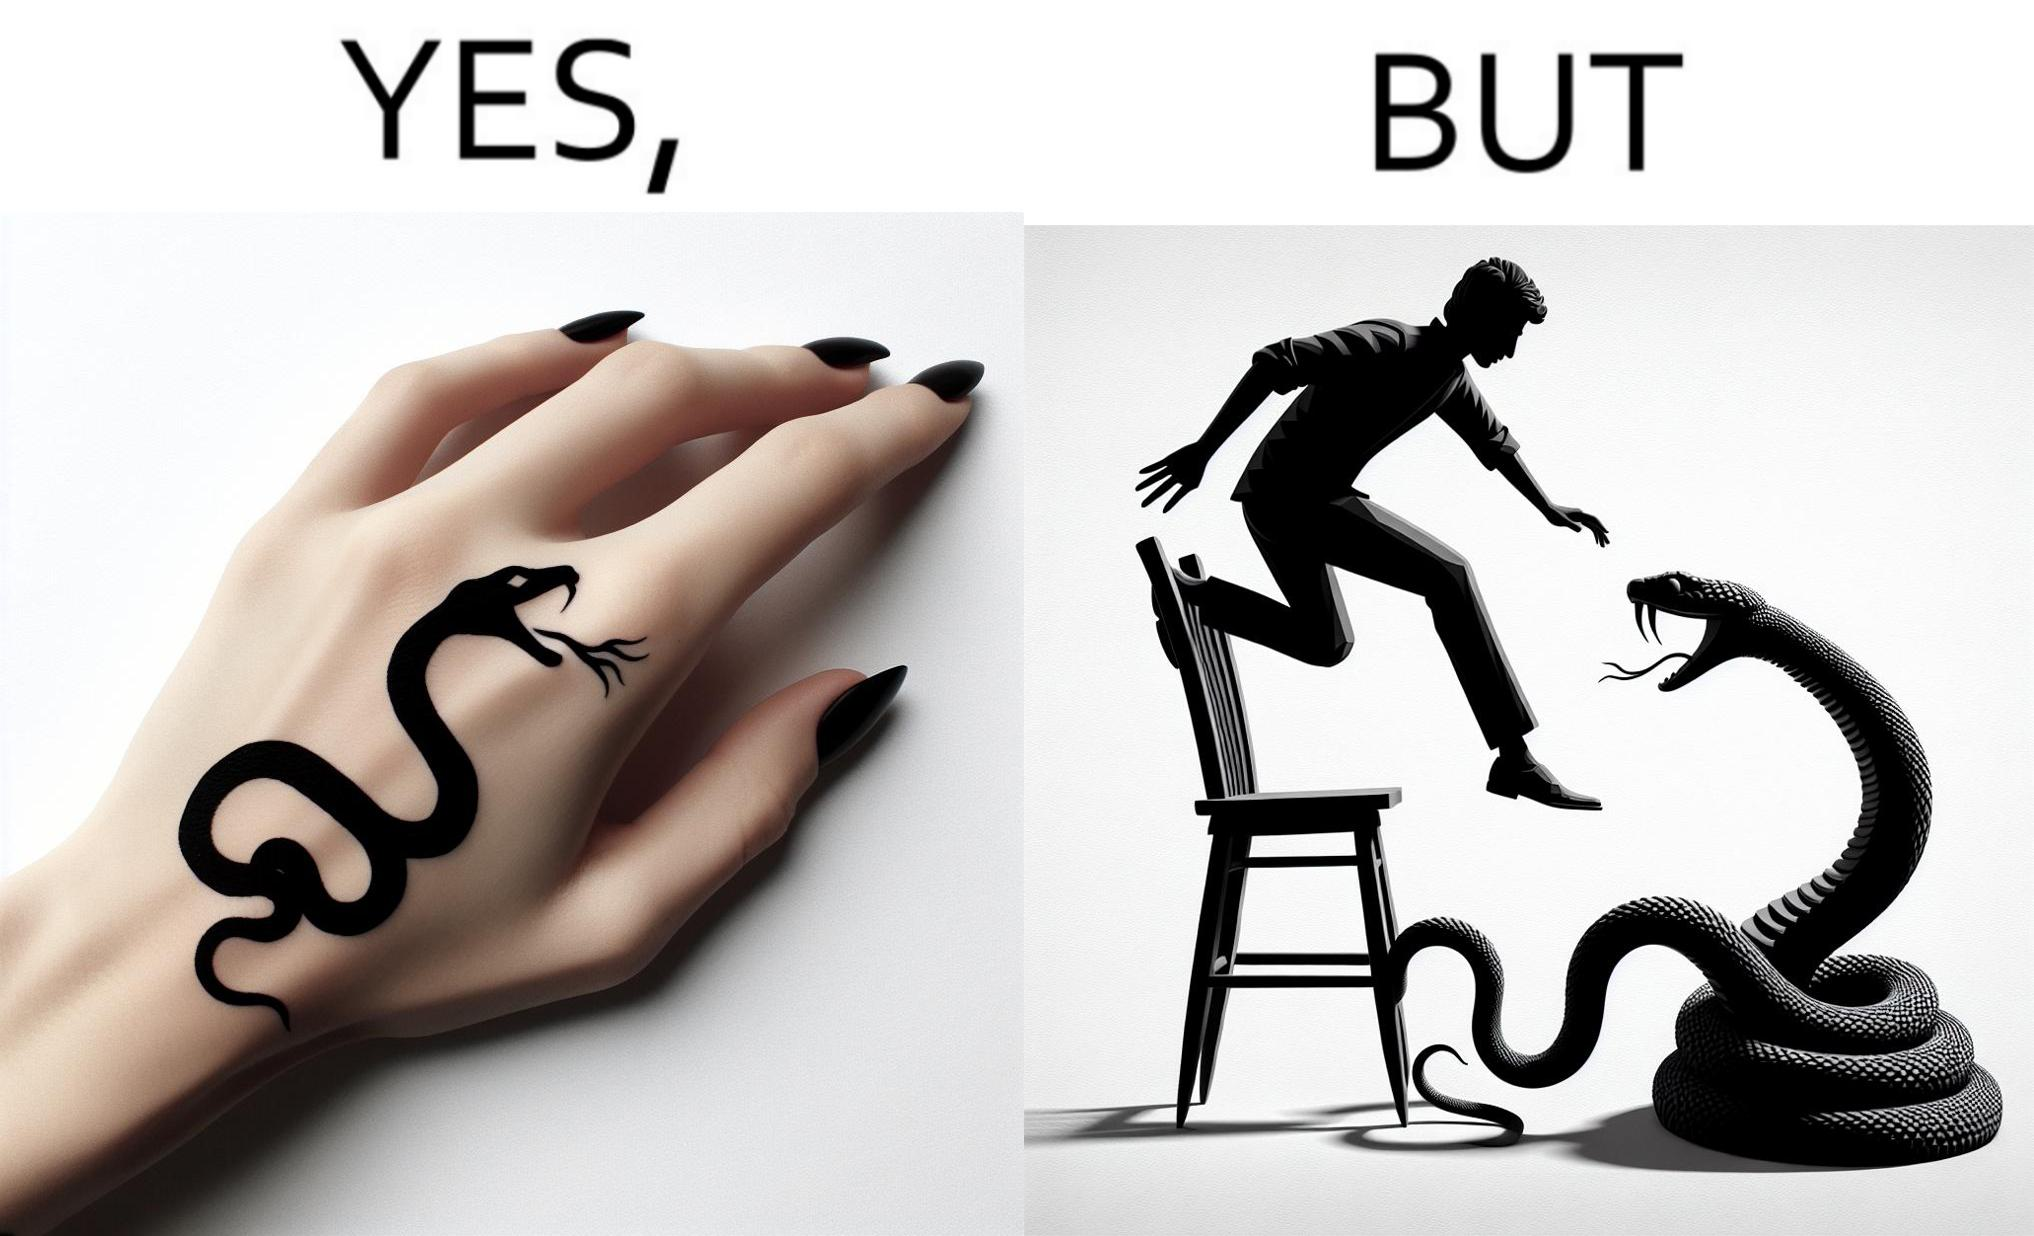Describe the contrast between the left and right parts of this image. In the left part of the image: a tattoo of a snake with its mouth wide open on someone's hand In the right part of the image: a person standing on a chair trying save himself from the attack of snake and the snake is probably trying to climb up the chair 